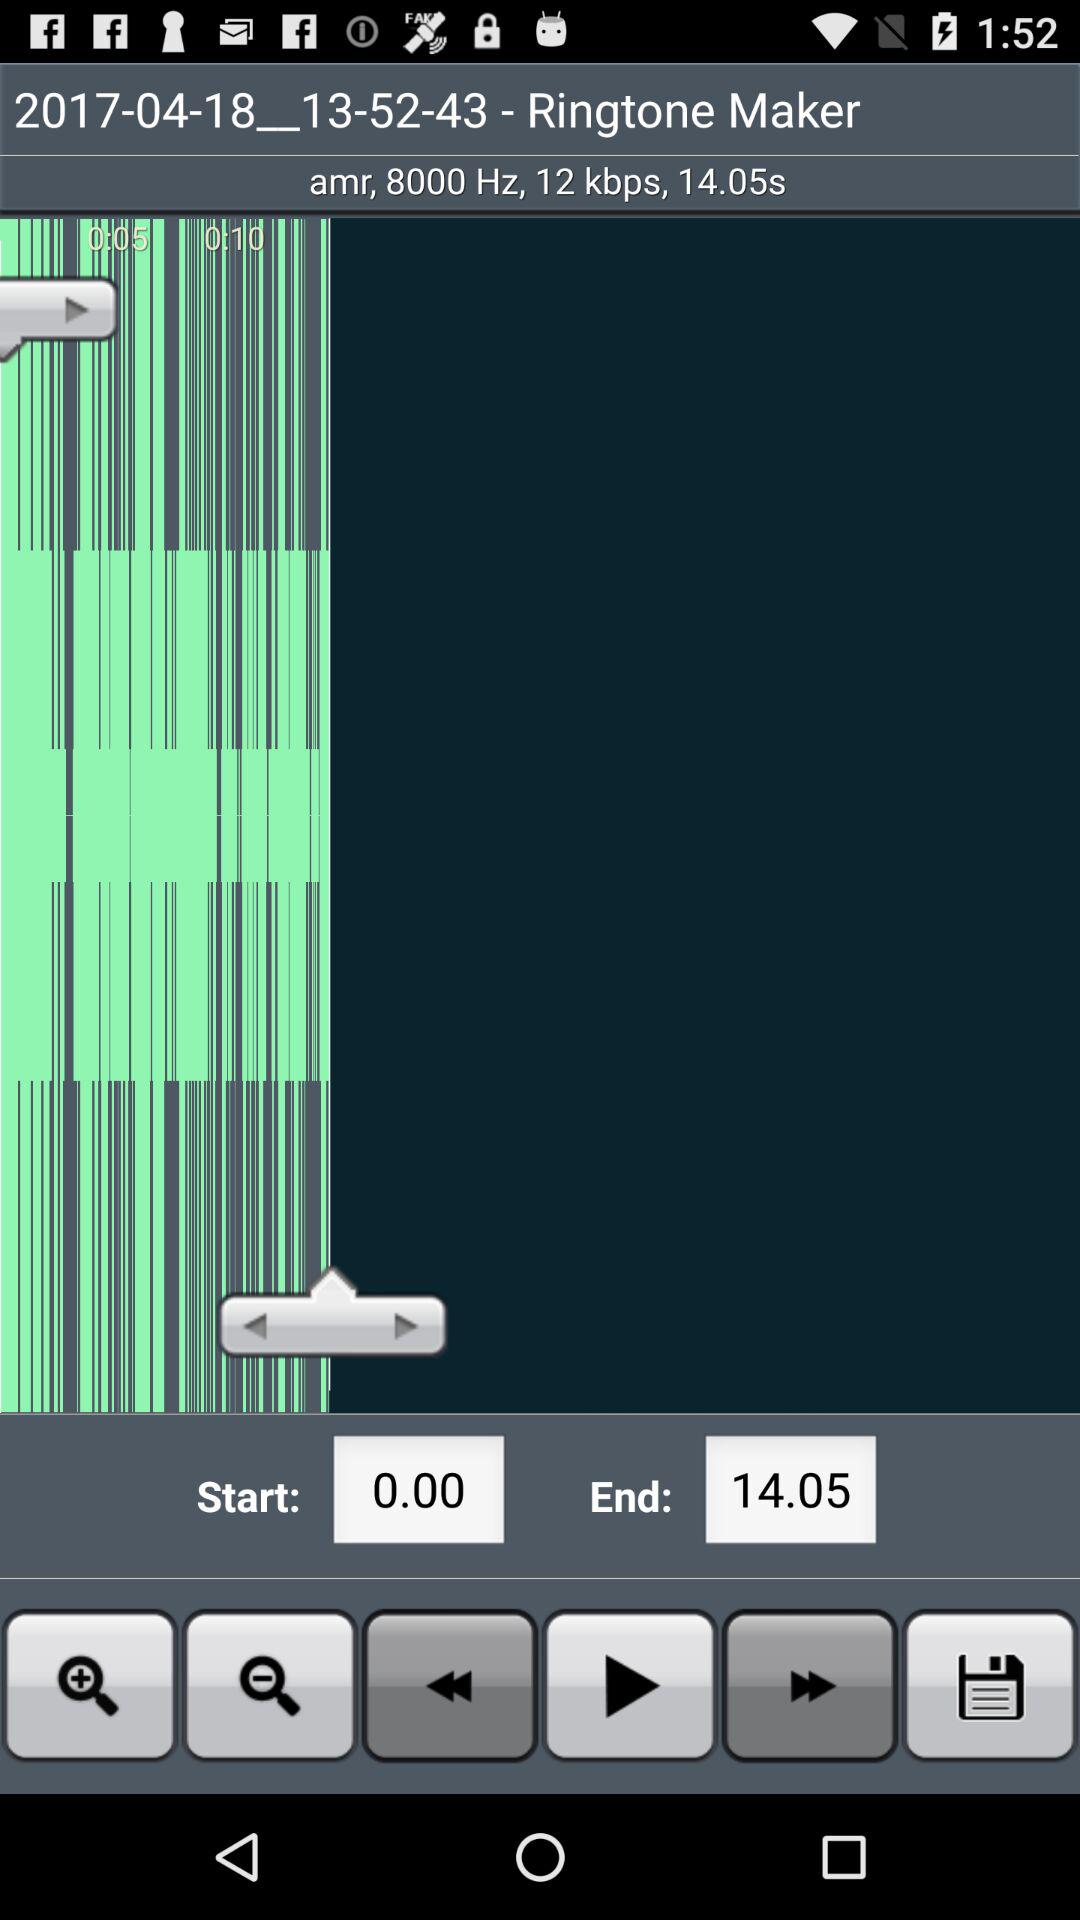How many seconds is the sound wave?
Answer the question using a single word or phrase. 14.05 